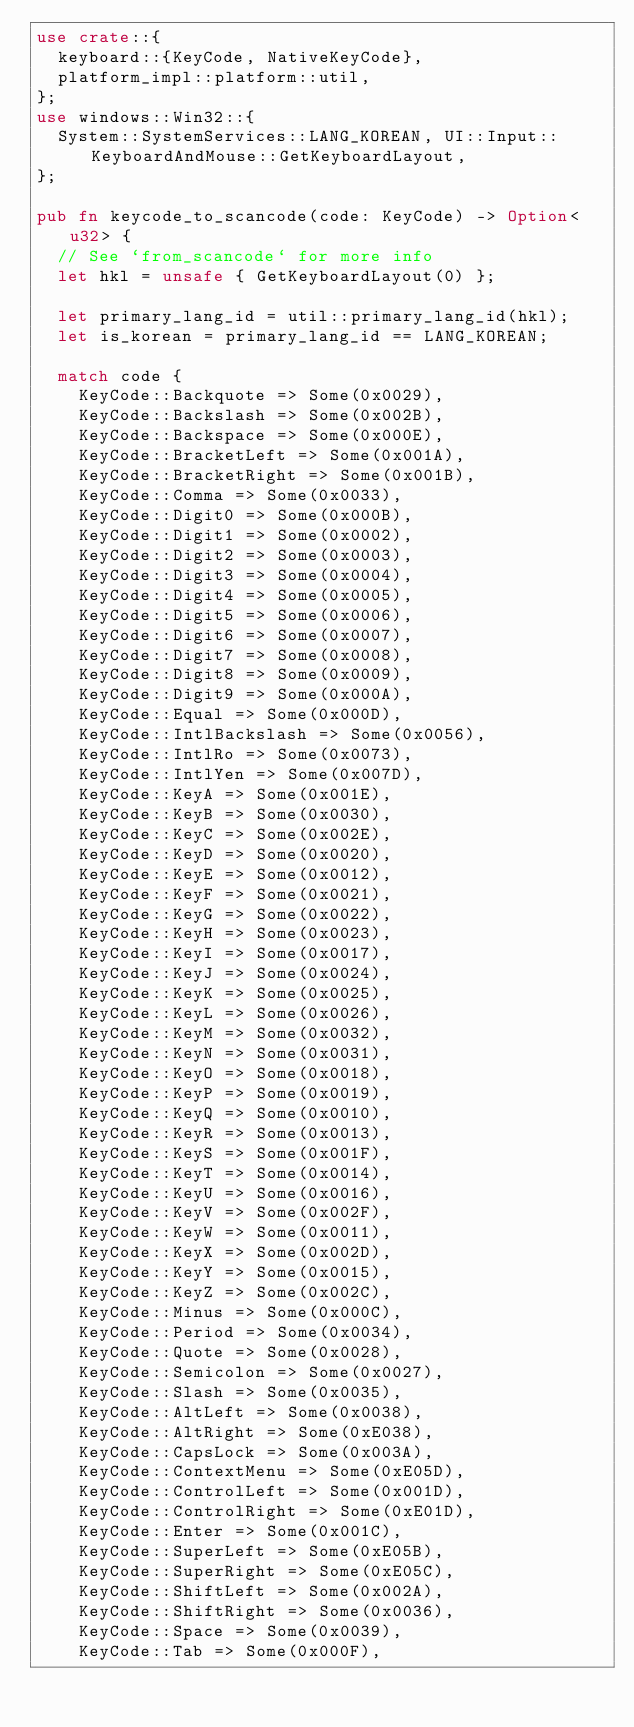<code> <loc_0><loc_0><loc_500><loc_500><_Rust_>use crate::{
  keyboard::{KeyCode, NativeKeyCode},
  platform_impl::platform::util,
};
use windows::Win32::{
  System::SystemServices::LANG_KOREAN, UI::Input::KeyboardAndMouse::GetKeyboardLayout,
};

pub fn keycode_to_scancode(code: KeyCode) -> Option<u32> {
  // See `from_scancode` for more info
  let hkl = unsafe { GetKeyboardLayout(0) };

  let primary_lang_id = util::primary_lang_id(hkl);
  let is_korean = primary_lang_id == LANG_KOREAN;

  match code {
    KeyCode::Backquote => Some(0x0029),
    KeyCode::Backslash => Some(0x002B),
    KeyCode::Backspace => Some(0x000E),
    KeyCode::BracketLeft => Some(0x001A),
    KeyCode::BracketRight => Some(0x001B),
    KeyCode::Comma => Some(0x0033),
    KeyCode::Digit0 => Some(0x000B),
    KeyCode::Digit1 => Some(0x0002),
    KeyCode::Digit2 => Some(0x0003),
    KeyCode::Digit3 => Some(0x0004),
    KeyCode::Digit4 => Some(0x0005),
    KeyCode::Digit5 => Some(0x0006),
    KeyCode::Digit6 => Some(0x0007),
    KeyCode::Digit7 => Some(0x0008),
    KeyCode::Digit8 => Some(0x0009),
    KeyCode::Digit9 => Some(0x000A),
    KeyCode::Equal => Some(0x000D),
    KeyCode::IntlBackslash => Some(0x0056),
    KeyCode::IntlRo => Some(0x0073),
    KeyCode::IntlYen => Some(0x007D),
    KeyCode::KeyA => Some(0x001E),
    KeyCode::KeyB => Some(0x0030),
    KeyCode::KeyC => Some(0x002E),
    KeyCode::KeyD => Some(0x0020),
    KeyCode::KeyE => Some(0x0012),
    KeyCode::KeyF => Some(0x0021),
    KeyCode::KeyG => Some(0x0022),
    KeyCode::KeyH => Some(0x0023),
    KeyCode::KeyI => Some(0x0017),
    KeyCode::KeyJ => Some(0x0024),
    KeyCode::KeyK => Some(0x0025),
    KeyCode::KeyL => Some(0x0026),
    KeyCode::KeyM => Some(0x0032),
    KeyCode::KeyN => Some(0x0031),
    KeyCode::KeyO => Some(0x0018),
    KeyCode::KeyP => Some(0x0019),
    KeyCode::KeyQ => Some(0x0010),
    KeyCode::KeyR => Some(0x0013),
    KeyCode::KeyS => Some(0x001F),
    KeyCode::KeyT => Some(0x0014),
    KeyCode::KeyU => Some(0x0016),
    KeyCode::KeyV => Some(0x002F),
    KeyCode::KeyW => Some(0x0011),
    KeyCode::KeyX => Some(0x002D),
    KeyCode::KeyY => Some(0x0015),
    KeyCode::KeyZ => Some(0x002C),
    KeyCode::Minus => Some(0x000C),
    KeyCode::Period => Some(0x0034),
    KeyCode::Quote => Some(0x0028),
    KeyCode::Semicolon => Some(0x0027),
    KeyCode::Slash => Some(0x0035),
    KeyCode::AltLeft => Some(0x0038),
    KeyCode::AltRight => Some(0xE038),
    KeyCode::CapsLock => Some(0x003A),
    KeyCode::ContextMenu => Some(0xE05D),
    KeyCode::ControlLeft => Some(0x001D),
    KeyCode::ControlRight => Some(0xE01D),
    KeyCode::Enter => Some(0x001C),
    KeyCode::SuperLeft => Some(0xE05B),
    KeyCode::SuperRight => Some(0xE05C),
    KeyCode::ShiftLeft => Some(0x002A),
    KeyCode::ShiftRight => Some(0x0036),
    KeyCode::Space => Some(0x0039),
    KeyCode::Tab => Some(0x000F),</code> 